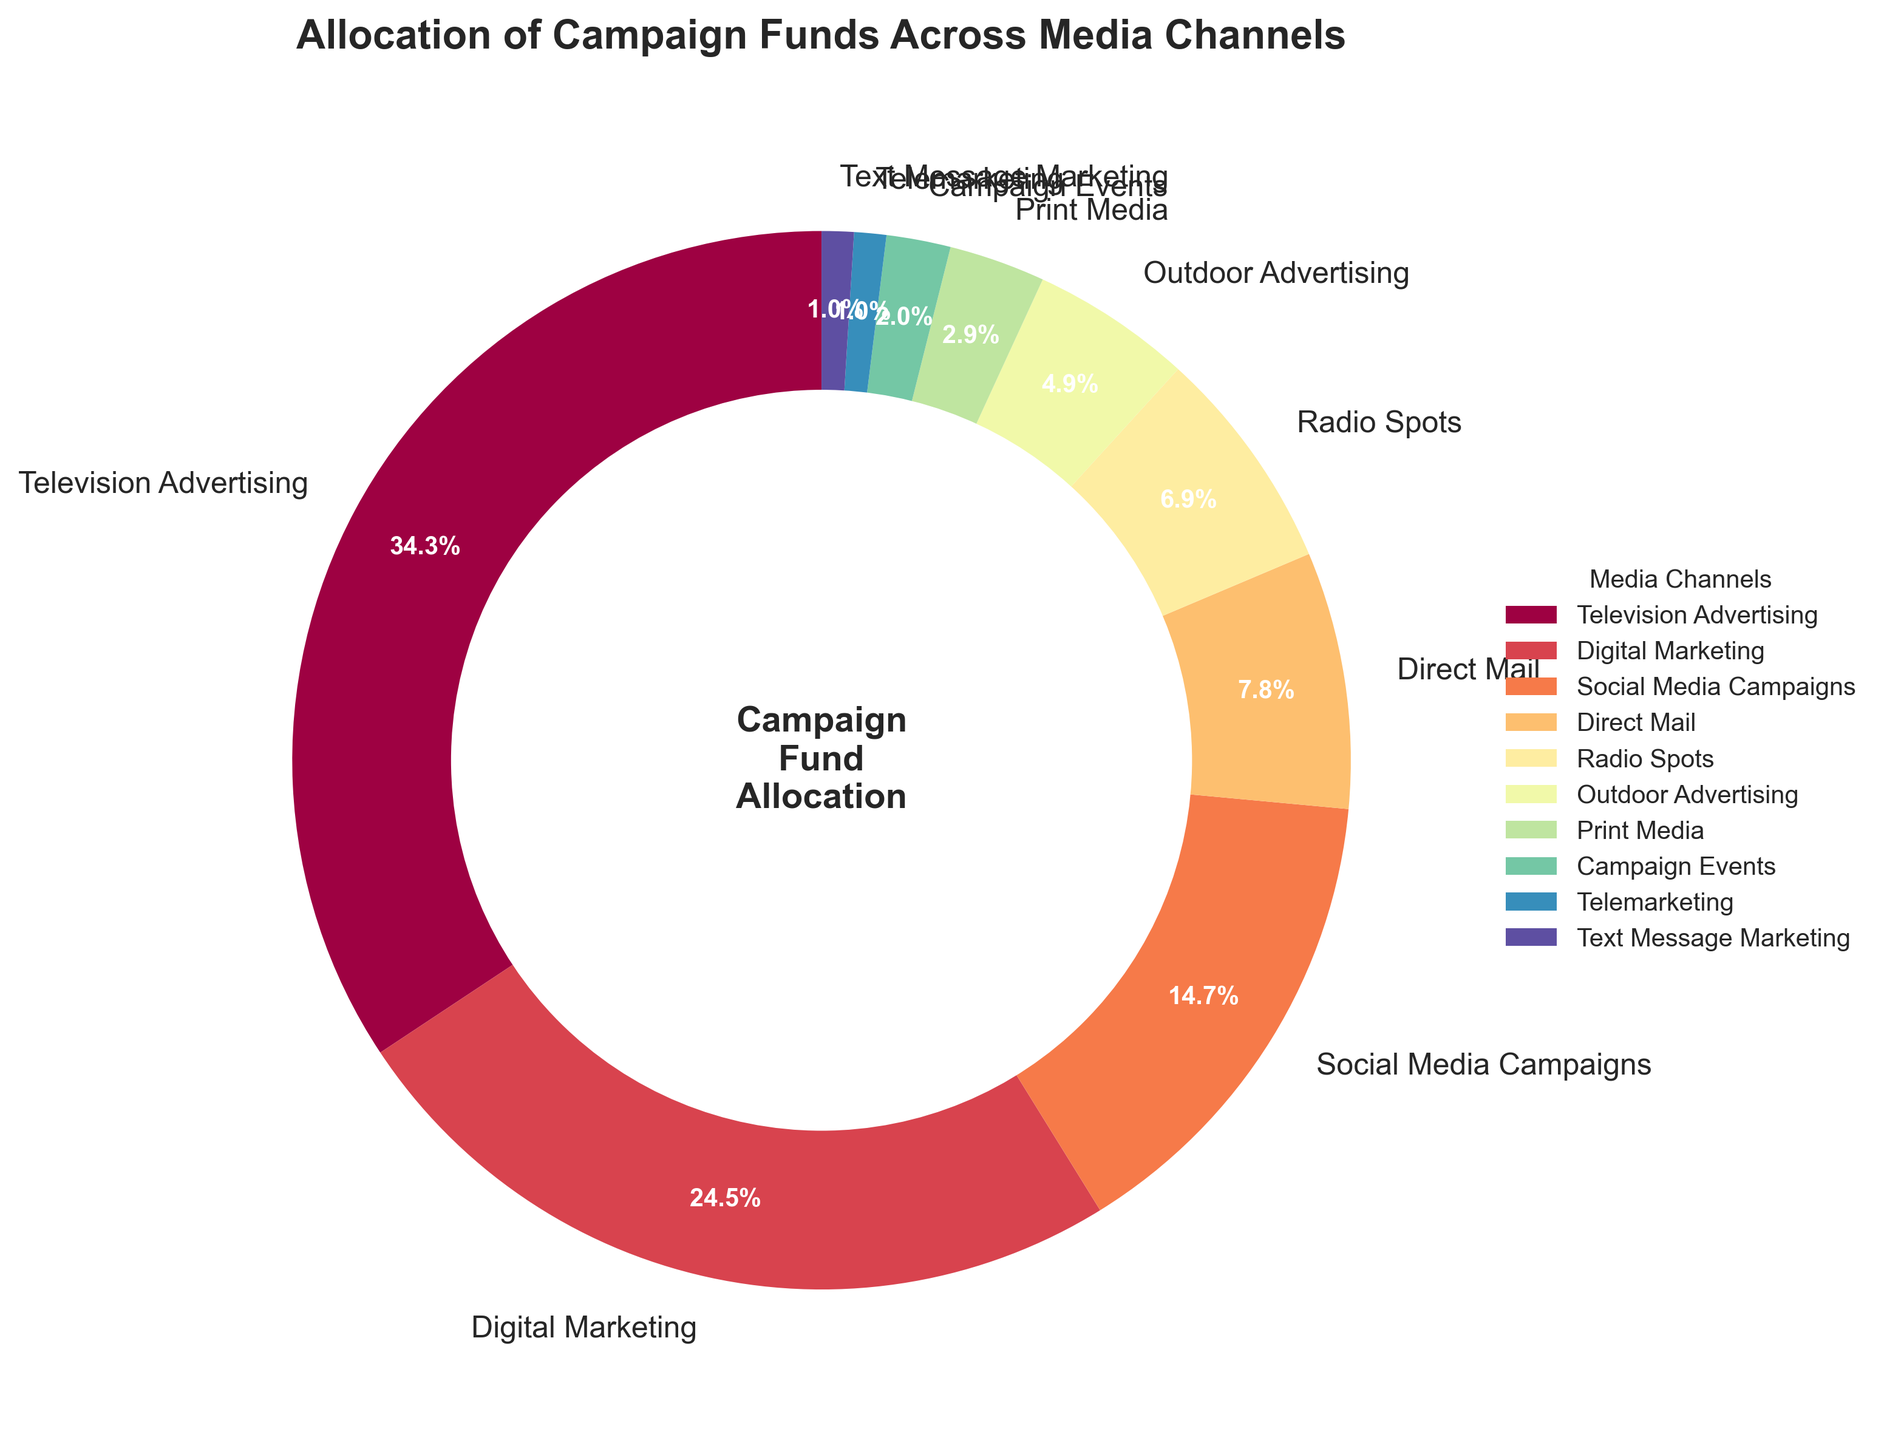Which media channel receives the highest allocation of campaign funds? The pie chart shows that Television Advertising has the largest segment, indicating it receives the highest percentage of funds.
Answer: Television Advertising How much higher is the allocation for Digital Marketing compared to Social Media Campaigns? Digital Marketing is allocated 25%, and Social Media Campaigns are allocated 15%. The difference is 25% - 15% = 10%.
Answer: 10% What percentage of the total campaign funds are allocated to outdoor advertising, print media, campaign events, telemarketing, and text message marketing combined? Adding up the allocations: 5% (Outdoor Advertising) + 3% (Print Media) + 2% (Campaign Events) + 1% (Telemarketing) + 1% (Text Message Marketing) = 12%.
Answer: 12% Is Radio Spots' fund allocation greater than Direct Mail's allocation? The pie chart shows that Radio Spots has 7%, while Direct Mail has 8%. Therefore, Radio Spots' allocation is not greater than Direct Mail's.
Answer: No What is the combined percentage allocated to Television Advertising and Digital Marketing? Television Advertising is allocated 35%, and Digital Marketing is allocated 25%. Their combined allocation is 35% + 25% = 60%.
Answer: 60% Which media channel has the smallest allocation of campaign funds, and what is its percentage? The pie chart shows both Telemarketing and Text Message Marketing have the smallest segments, each allocated 1%.
Answer: Telemarketing and Text Message Marketing, 1% How much more is allocated to Television Advertising than Social Media Campaigns? Television Advertising is allocated 35%, and Social Media Campaigns are allocated 15%. The difference is 35% - 15% = 20%.
Answer: 20% Among the top three media channels in the allocation of campaign funds, what is the total percentage they account for? The top three media channels are Television Advertising (35%), Digital Marketing (25%), and Social Media Campaigns (15%). Their total percentage is 35% + 25% + 15% = 75%.
Answer: 75% What percentage of the campaign funds are allocated to non-digital channels (Television Advertising, Direct Mail, Radio Spots, Outdoor Advertising, Print Media, Campaign Events)? Adding the allocations: 35% (Television Advertising) + 8% (Direct Mail) + 7% (Radio Spots) + 5% (Outdoor Advertising) + 3% (Print Media) + 2% (Campaign Events) = 60%.
Answer: 60% If we combine the allocations for all digital media channels (Digital Marketing, Social Media Campaigns, Text Message Marketing), what is the combined percentage? Adding the allocations: 25% (Digital Marketing) + 15% (Social Media Campaigns) + 1% (Text Message Marketing) = 41%.
Answer: 41% 